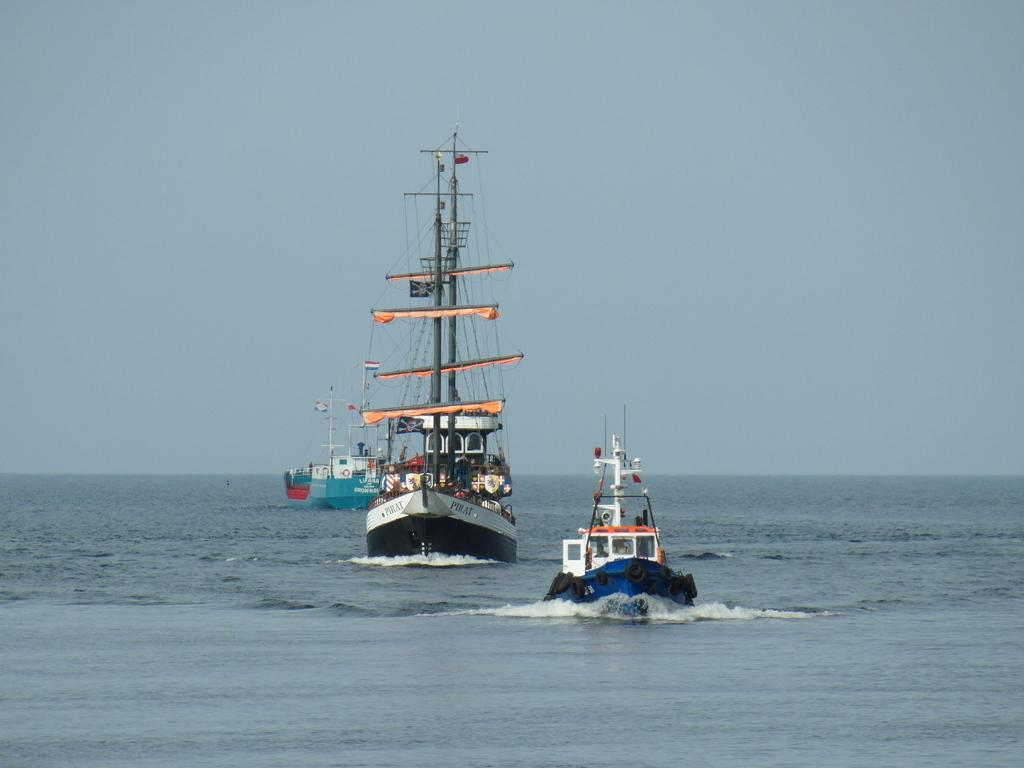What is the main subject of the image? The main subject of the image is ships. What is the ships' location in relation to the water? The ships are sailing on the water. What else can be seen in the image besides the ships? The sky is visible in the image. What type of lace can be seen on the side of the ships in the image? There is no lace present on the ships in the image. How many wrens are perched on the masts of the ships in the image? There are no wrens present on the ships in the image. 